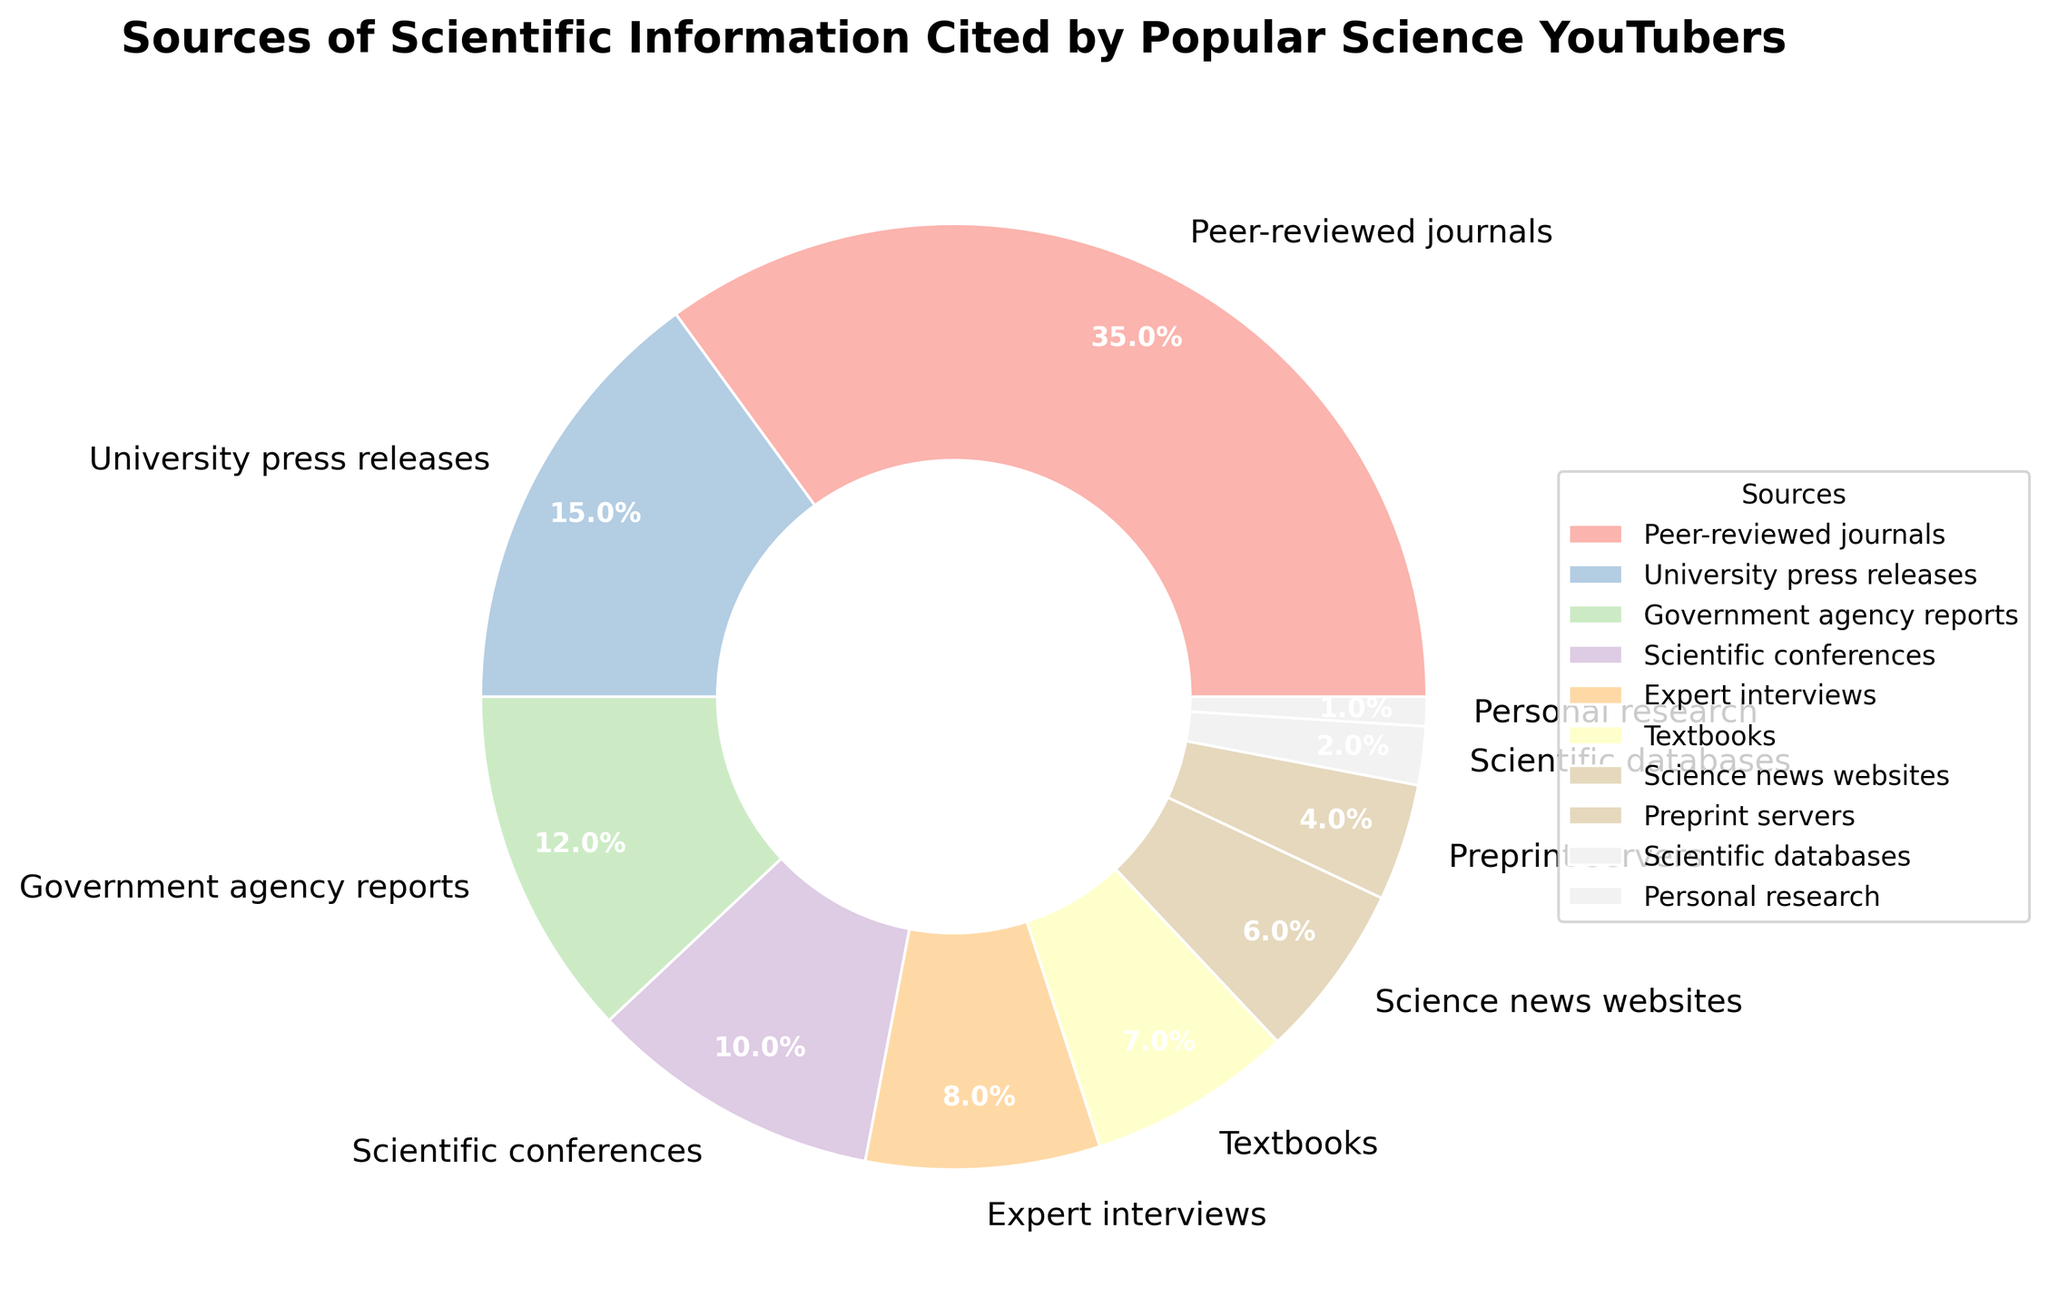What percentage of total sources are represented by Peer-reviewed journals and Expert interviews combined? To find the combined percentage, add the percentage of Peer-reviewed journals (35%) and Expert interviews (8%). Thus, 35% + 8% = 43%.
Answer: 43% Which source is the least cited and what is its percentage? The source with the smallest percentage is Personal research, which has a percentage of 1%.
Answer: Personal research, 1% Compare the percentages of information from Government agency reports and Science news websites. Which is higher and by how much? Government agency reports have a percentage of 12%, while Science news websites have 6%. The difference is 12% - 6% = 6%. Therefore, Government agency reports are higher by 6%.
Answer: Government agency reports, 6% What is the difference in the percentage between University press releases and Preprint servers? University press releases have a percentage of 15%, and Preprint servers have 4%. The difference is 15% - 4% = 11%.
Answer: 11% Which three sources contribute equally to the overall percentages, and what is their combined percentage? The three sources that contribute equally are Scientific conferences (10%), Expert interviews (8%), and Textbooks (7%). To find the combined percentage, add 10% + 8% + 7% = 25%.
Answer: Scientific conferences, Expert interviews, Textbooks; 25% Calculate the average percentage contribution of Government agency reports, Scientific conferences, and Science news websites. Sum the percentages of Government agency reports (12%), Scientific conferences (10%), and Science news websites (6%). Then, divide by the number of sources: (12% + 10% + 6%) / 3 = 9.33%.
Answer: 9.33% Which source has a contribution closest to the overall median percentage of all sources? To find the median, the percentages are ordered: 1, 2, 4, 6, 7, 8, 10, 12, 15, 35. The median is the average of the 5th and 6th values: (7 + 8) / 2 = 7.5. The source closest to 7.5% is Textbooks, which has 7%.
Answer: Textbooks Identify the two sources whose combined total percentages equal the percentage of Peer-reviewed journals. Peer-reviewed journals have 35%. The two sources that add up to 35% are University press releases (15%) and Government agency reports (12%) combined with Science news websites (6%). Therefore, 15% + 12% + 6% = 33%. The closest is University press releases (15%) + Scientific conferences (10%) + Textbooks (7%) + Scientific databases (2%) + Personal research (1%) = 35%.
Answer: University press releases + Scientific conferences + Textbooks + Scientific databases + Personal research What is the second most cited source of scientific information, and what is its percentage? The second most cited source is University press releases, with a percentage of 15%.
Answer: University press releases, 15% Which category represents less than 5% of the citations? Preprint servers (4%) and Scientific databases (2%) both represent less than 5% of the citations.
Answer: Preprint servers, Scientific databases 